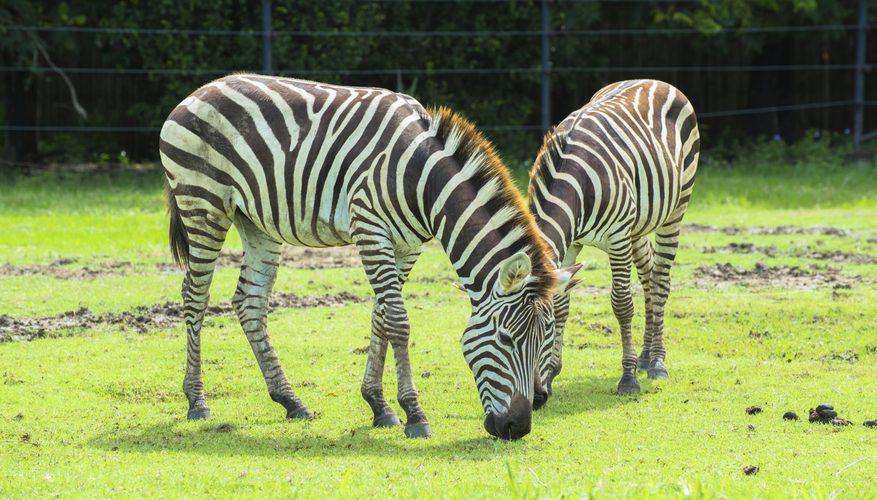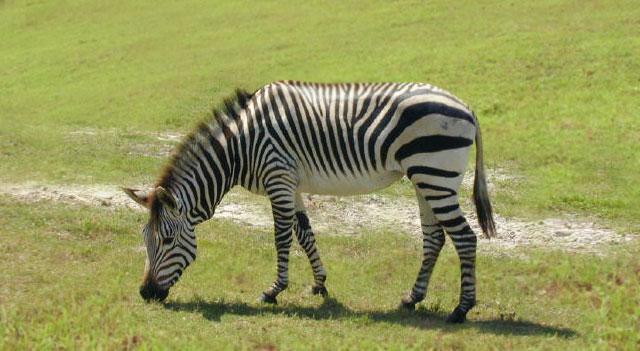The first image is the image on the left, the second image is the image on the right. Examine the images to the left and right. Is the description "The right image contains one zebra with lowered head and body in profile, and the left image features two zebras side-to-side with bodies parallel." accurate? Answer yes or no. No. 